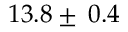<formula> <loc_0><loc_0><loc_500><loc_500>1 3 . 8 \pm \, 0 . 4</formula> 